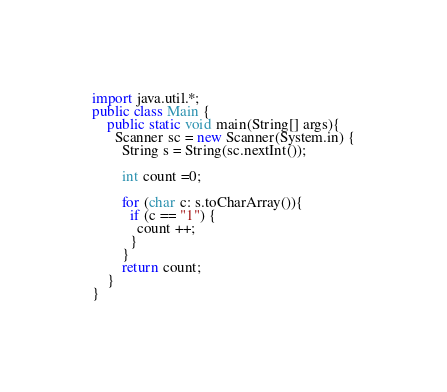<code> <loc_0><loc_0><loc_500><loc_500><_Java_>import java.util.*;
public class Main {
    public static void main(String[] args){
      Scanner sc = new Scanner(System.in) {
        String s = String(sc.nextInt());
        
        int count =0;
        
        for (char c: s.toCharArray()){
          if (c == "1") {
            count ++;
          }
		}
        return count;
	}
}</code> 